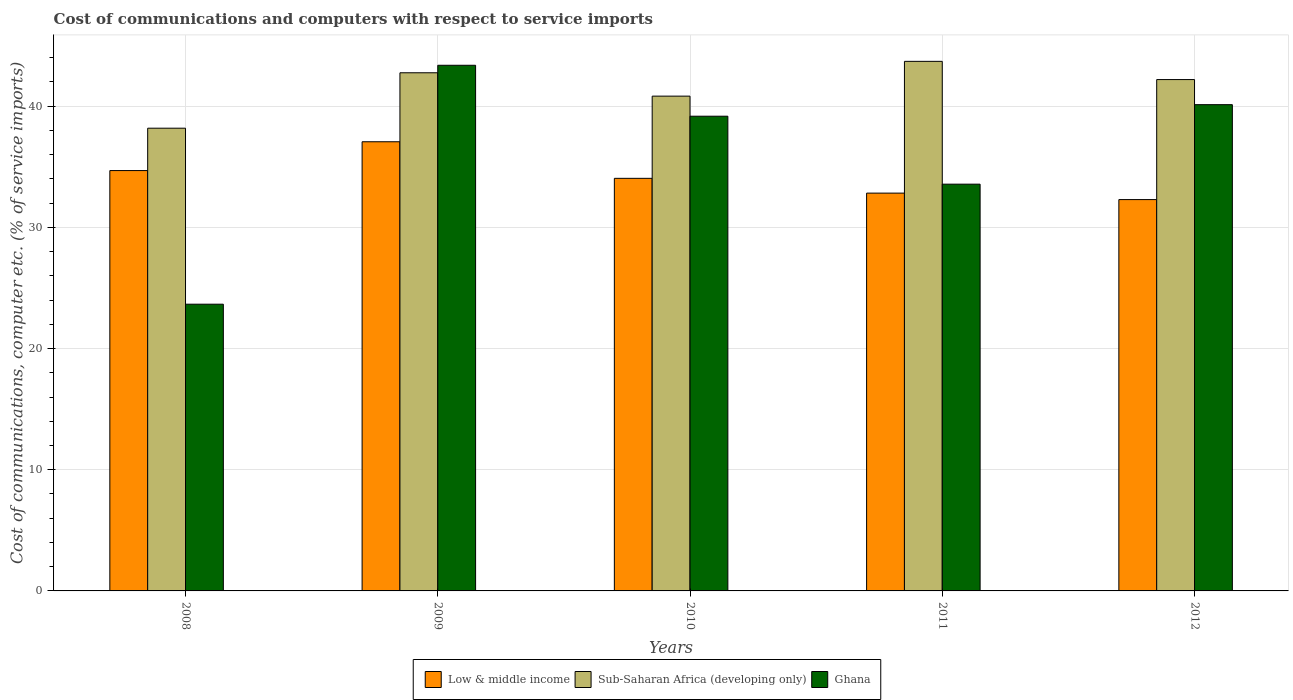How many different coloured bars are there?
Provide a short and direct response. 3. How many groups of bars are there?
Provide a short and direct response. 5. How many bars are there on the 2nd tick from the left?
Your answer should be very brief. 3. What is the cost of communications and computers in Low & middle income in 2011?
Your response must be concise. 32.83. Across all years, what is the maximum cost of communications and computers in Low & middle income?
Ensure brevity in your answer.  37.07. Across all years, what is the minimum cost of communications and computers in Ghana?
Your answer should be compact. 23.66. In which year was the cost of communications and computers in Ghana maximum?
Make the answer very short. 2009. What is the total cost of communications and computers in Low & middle income in the graph?
Keep it short and to the point. 170.93. What is the difference between the cost of communications and computers in Low & middle income in 2009 and that in 2011?
Offer a terse response. 4.24. What is the difference between the cost of communications and computers in Sub-Saharan Africa (developing only) in 2011 and the cost of communications and computers in Low & middle income in 2009?
Your answer should be compact. 6.64. What is the average cost of communications and computers in Low & middle income per year?
Keep it short and to the point. 34.19. In the year 2011, what is the difference between the cost of communications and computers in Ghana and cost of communications and computers in Sub-Saharan Africa (developing only)?
Give a very brief answer. -10.13. In how many years, is the cost of communications and computers in Sub-Saharan Africa (developing only) greater than 40 %?
Offer a very short reply. 4. What is the ratio of the cost of communications and computers in Low & middle income in 2010 to that in 2011?
Ensure brevity in your answer.  1.04. Is the cost of communications and computers in Ghana in 2010 less than that in 2012?
Your answer should be compact. Yes. What is the difference between the highest and the second highest cost of communications and computers in Low & middle income?
Your response must be concise. 2.38. What is the difference between the highest and the lowest cost of communications and computers in Low & middle income?
Make the answer very short. 4.77. Is the sum of the cost of communications and computers in Ghana in 2011 and 2012 greater than the maximum cost of communications and computers in Low & middle income across all years?
Offer a very short reply. Yes. How many bars are there?
Give a very brief answer. 15. Are all the bars in the graph horizontal?
Keep it short and to the point. No. How many years are there in the graph?
Provide a succinct answer. 5. Does the graph contain any zero values?
Offer a terse response. No. Where does the legend appear in the graph?
Your response must be concise. Bottom center. How are the legend labels stacked?
Your answer should be very brief. Horizontal. What is the title of the graph?
Offer a very short reply. Cost of communications and computers with respect to service imports. Does "Canada" appear as one of the legend labels in the graph?
Make the answer very short. No. What is the label or title of the Y-axis?
Provide a succinct answer. Cost of communications, computer etc. (% of service imports). What is the Cost of communications, computer etc. (% of service imports) of Low & middle income in 2008?
Give a very brief answer. 34.69. What is the Cost of communications, computer etc. (% of service imports) of Sub-Saharan Africa (developing only) in 2008?
Make the answer very short. 38.19. What is the Cost of communications, computer etc. (% of service imports) in Ghana in 2008?
Provide a short and direct response. 23.66. What is the Cost of communications, computer etc. (% of service imports) in Low & middle income in 2009?
Provide a succinct answer. 37.07. What is the Cost of communications, computer etc. (% of service imports) in Sub-Saharan Africa (developing only) in 2009?
Provide a succinct answer. 42.76. What is the Cost of communications, computer etc. (% of service imports) in Ghana in 2009?
Make the answer very short. 43.38. What is the Cost of communications, computer etc. (% of service imports) in Low & middle income in 2010?
Offer a terse response. 34.05. What is the Cost of communications, computer etc. (% of service imports) in Sub-Saharan Africa (developing only) in 2010?
Offer a very short reply. 40.83. What is the Cost of communications, computer etc. (% of service imports) in Ghana in 2010?
Your answer should be very brief. 39.18. What is the Cost of communications, computer etc. (% of service imports) of Low & middle income in 2011?
Your answer should be very brief. 32.83. What is the Cost of communications, computer etc. (% of service imports) in Sub-Saharan Africa (developing only) in 2011?
Your response must be concise. 43.7. What is the Cost of communications, computer etc. (% of service imports) of Ghana in 2011?
Your answer should be compact. 33.57. What is the Cost of communications, computer etc. (% of service imports) in Low & middle income in 2012?
Provide a short and direct response. 32.3. What is the Cost of communications, computer etc. (% of service imports) of Sub-Saharan Africa (developing only) in 2012?
Give a very brief answer. 42.2. What is the Cost of communications, computer etc. (% of service imports) in Ghana in 2012?
Your response must be concise. 40.13. Across all years, what is the maximum Cost of communications, computer etc. (% of service imports) of Low & middle income?
Provide a short and direct response. 37.07. Across all years, what is the maximum Cost of communications, computer etc. (% of service imports) in Sub-Saharan Africa (developing only)?
Your response must be concise. 43.7. Across all years, what is the maximum Cost of communications, computer etc. (% of service imports) in Ghana?
Offer a very short reply. 43.38. Across all years, what is the minimum Cost of communications, computer etc. (% of service imports) of Low & middle income?
Give a very brief answer. 32.3. Across all years, what is the minimum Cost of communications, computer etc. (% of service imports) of Sub-Saharan Africa (developing only)?
Your response must be concise. 38.19. Across all years, what is the minimum Cost of communications, computer etc. (% of service imports) in Ghana?
Ensure brevity in your answer.  23.66. What is the total Cost of communications, computer etc. (% of service imports) in Low & middle income in the graph?
Keep it short and to the point. 170.93. What is the total Cost of communications, computer etc. (% of service imports) of Sub-Saharan Africa (developing only) in the graph?
Give a very brief answer. 207.69. What is the total Cost of communications, computer etc. (% of service imports) of Ghana in the graph?
Offer a very short reply. 179.92. What is the difference between the Cost of communications, computer etc. (% of service imports) of Low & middle income in 2008 and that in 2009?
Provide a succinct answer. -2.38. What is the difference between the Cost of communications, computer etc. (% of service imports) of Sub-Saharan Africa (developing only) in 2008 and that in 2009?
Provide a succinct answer. -4.57. What is the difference between the Cost of communications, computer etc. (% of service imports) in Ghana in 2008 and that in 2009?
Provide a short and direct response. -19.72. What is the difference between the Cost of communications, computer etc. (% of service imports) in Low & middle income in 2008 and that in 2010?
Your response must be concise. 0.64. What is the difference between the Cost of communications, computer etc. (% of service imports) in Sub-Saharan Africa (developing only) in 2008 and that in 2010?
Offer a terse response. -2.65. What is the difference between the Cost of communications, computer etc. (% of service imports) of Ghana in 2008 and that in 2010?
Give a very brief answer. -15.51. What is the difference between the Cost of communications, computer etc. (% of service imports) of Low & middle income in 2008 and that in 2011?
Provide a short and direct response. 1.86. What is the difference between the Cost of communications, computer etc. (% of service imports) of Sub-Saharan Africa (developing only) in 2008 and that in 2011?
Your answer should be compact. -5.52. What is the difference between the Cost of communications, computer etc. (% of service imports) of Ghana in 2008 and that in 2011?
Offer a very short reply. -9.91. What is the difference between the Cost of communications, computer etc. (% of service imports) in Low & middle income in 2008 and that in 2012?
Keep it short and to the point. 2.39. What is the difference between the Cost of communications, computer etc. (% of service imports) of Sub-Saharan Africa (developing only) in 2008 and that in 2012?
Make the answer very short. -4.01. What is the difference between the Cost of communications, computer etc. (% of service imports) of Ghana in 2008 and that in 2012?
Keep it short and to the point. -16.47. What is the difference between the Cost of communications, computer etc. (% of service imports) of Low & middle income in 2009 and that in 2010?
Keep it short and to the point. 3.02. What is the difference between the Cost of communications, computer etc. (% of service imports) of Sub-Saharan Africa (developing only) in 2009 and that in 2010?
Your answer should be compact. 1.93. What is the difference between the Cost of communications, computer etc. (% of service imports) in Ghana in 2009 and that in 2010?
Offer a terse response. 4.2. What is the difference between the Cost of communications, computer etc. (% of service imports) of Low & middle income in 2009 and that in 2011?
Your answer should be very brief. 4.24. What is the difference between the Cost of communications, computer etc. (% of service imports) in Sub-Saharan Africa (developing only) in 2009 and that in 2011?
Ensure brevity in your answer.  -0.94. What is the difference between the Cost of communications, computer etc. (% of service imports) of Ghana in 2009 and that in 2011?
Ensure brevity in your answer.  9.81. What is the difference between the Cost of communications, computer etc. (% of service imports) in Low & middle income in 2009 and that in 2012?
Provide a short and direct response. 4.77. What is the difference between the Cost of communications, computer etc. (% of service imports) in Sub-Saharan Africa (developing only) in 2009 and that in 2012?
Your answer should be very brief. 0.56. What is the difference between the Cost of communications, computer etc. (% of service imports) of Ghana in 2009 and that in 2012?
Make the answer very short. 3.25. What is the difference between the Cost of communications, computer etc. (% of service imports) of Low & middle income in 2010 and that in 2011?
Ensure brevity in your answer.  1.22. What is the difference between the Cost of communications, computer etc. (% of service imports) in Sub-Saharan Africa (developing only) in 2010 and that in 2011?
Make the answer very short. -2.87. What is the difference between the Cost of communications, computer etc. (% of service imports) of Ghana in 2010 and that in 2011?
Ensure brevity in your answer.  5.61. What is the difference between the Cost of communications, computer etc. (% of service imports) in Low & middle income in 2010 and that in 2012?
Make the answer very short. 1.75. What is the difference between the Cost of communications, computer etc. (% of service imports) in Sub-Saharan Africa (developing only) in 2010 and that in 2012?
Give a very brief answer. -1.37. What is the difference between the Cost of communications, computer etc. (% of service imports) of Ghana in 2010 and that in 2012?
Keep it short and to the point. -0.95. What is the difference between the Cost of communications, computer etc. (% of service imports) of Low & middle income in 2011 and that in 2012?
Ensure brevity in your answer.  0.53. What is the difference between the Cost of communications, computer etc. (% of service imports) of Sub-Saharan Africa (developing only) in 2011 and that in 2012?
Give a very brief answer. 1.5. What is the difference between the Cost of communications, computer etc. (% of service imports) of Ghana in 2011 and that in 2012?
Make the answer very short. -6.56. What is the difference between the Cost of communications, computer etc. (% of service imports) in Low & middle income in 2008 and the Cost of communications, computer etc. (% of service imports) in Sub-Saharan Africa (developing only) in 2009?
Ensure brevity in your answer.  -8.07. What is the difference between the Cost of communications, computer etc. (% of service imports) of Low & middle income in 2008 and the Cost of communications, computer etc. (% of service imports) of Ghana in 2009?
Offer a very short reply. -8.69. What is the difference between the Cost of communications, computer etc. (% of service imports) in Sub-Saharan Africa (developing only) in 2008 and the Cost of communications, computer etc. (% of service imports) in Ghana in 2009?
Make the answer very short. -5.19. What is the difference between the Cost of communications, computer etc. (% of service imports) in Low & middle income in 2008 and the Cost of communications, computer etc. (% of service imports) in Sub-Saharan Africa (developing only) in 2010?
Your answer should be very brief. -6.14. What is the difference between the Cost of communications, computer etc. (% of service imports) in Low & middle income in 2008 and the Cost of communications, computer etc. (% of service imports) in Ghana in 2010?
Your answer should be compact. -4.49. What is the difference between the Cost of communications, computer etc. (% of service imports) of Sub-Saharan Africa (developing only) in 2008 and the Cost of communications, computer etc. (% of service imports) of Ghana in 2010?
Make the answer very short. -0.99. What is the difference between the Cost of communications, computer etc. (% of service imports) of Low & middle income in 2008 and the Cost of communications, computer etc. (% of service imports) of Sub-Saharan Africa (developing only) in 2011?
Provide a succinct answer. -9.01. What is the difference between the Cost of communications, computer etc. (% of service imports) in Low & middle income in 2008 and the Cost of communications, computer etc. (% of service imports) in Ghana in 2011?
Your answer should be very brief. 1.12. What is the difference between the Cost of communications, computer etc. (% of service imports) of Sub-Saharan Africa (developing only) in 2008 and the Cost of communications, computer etc. (% of service imports) of Ghana in 2011?
Your answer should be very brief. 4.62. What is the difference between the Cost of communications, computer etc. (% of service imports) in Low & middle income in 2008 and the Cost of communications, computer etc. (% of service imports) in Sub-Saharan Africa (developing only) in 2012?
Make the answer very short. -7.51. What is the difference between the Cost of communications, computer etc. (% of service imports) of Low & middle income in 2008 and the Cost of communications, computer etc. (% of service imports) of Ghana in 2012?
Offer a terse response. -5.44. What is the difference between the Cost of communications, computer etc. (% of service imports) of Sub-Saharan Africa (developing only) in 2008 and the Cost of communications, computer etc. (% of service imports) of Ghana in 2012?
Your response must be concise. -1.94. What is the difference between the Cost of communications, computer etc. (% of service imports) in Low & middle income in 2009 and the Cost of communications, computer etc. (% of service imports) in Sub-Saharan Africa (developing only) in 2010?
Ensure brevity in your answer.  -3.77. What is the difference between the Cost of communications, computer etc. (% of service imports) of Low & middle income in 2009 and the Cost of communications, computer etc. (% of service imports) of Ghana in 2010?
Provide a short and direct response. -2.11. What is the difference between the Cost of communications, computer etc. (% of service imports) in Sub-Saharan Africa (developing only) in 2009 and the Cost of communications, computer etc. (% of service imports) in Ghana in 2010?
Your response must be concise. 3.59. What is the difference between the Cost of communications, computer etc. (% of service imports) of Low & middle income in 2009 and the Cost of communications, computer etc. (% of service imports) of Sub-Saharan Africa (developing only) in 2011?
Make the answer very short. -6.64. What is the difference between the Cost of communications, computer etc. (% of service imports) of Low & middle income in 2009 and the Cost of communications, computer etc. (% of service imports) of Ghana in 2011?
Offer a very short reply. 3.5. What is the difference between the Cost of communications, computer etc. (% of service imports) of Sub-Saharan Africa (developing only) in 2009 and the Cost of communications, computer etc. (% of service imports) of Ghana in 2011?
Provide a short and direct response. 9.19. What is the difference between the Cost of communications, computer etc. (% of service imports) in Low & middle income in 2009 and the Cost of communications, computer etc. (% of service imports) in Sub-Saharan Africa (developing only) in 2012?
Your response must be concise. -5.13. What is the difference between the Cost of communications, computer etc. (% of service imports) in Low & middle income in 2009 and the Cost of communications, computer etc. (% of service imports) in Ghana in 2012?
Give a very brief answer. -3.06. What is the difference between the Cost of communications, computer etc. (% of service imports) of Sub-Saharan Africa (developing only) in 2009 and the Cost of communications, computer etc. (% of service imports) of Ghana in 2012?
Provide a short and direct response. 2.63. What is the difference between the Cost of communications, computer etc. (% of service imports) in Low & middle income in 2010 and the Cost of communications, computer etc. (% of service imports) in Sub-Saharan Africa (developing only) in 2011?
Offer a terse response. -9.65. What is the difference between the Cost of communications, computer etc. (% of service imports) of Low & middle income in 2010 and the Cost of communications, computer etc. (% of service imports) of Ghana in 2011?
Your response must be concise. 0.48. What is the difference between the Cost of communications, computer etc. (% of service imports) of Sub-Saharan Africa (developing only) in 2010 and the Cost of communications, computer etc. (% of service imports) of Ghana in 2011?
Your answer should be compact. 7.26. What is the difference between the Cost of communications, computer etc. (% of service imports) in Low & middle income in 2010 and the Cost of communications, computer etc. (% of service imports) in Sub-Saharan Africa (developing only) in 2012?
Make the answer very short. -8.15. What is the difference between the Cost of communications, computer etc. (% of service imports) in Low & middle income in 2010 and the Cost of communications, computer etc. (% of service imports) in Ghana in 2012?
Offer a very short reply. -6.08. What is the difference between the Cost of communications, computer etc. (% of service imports) in Sub-Saharan Africa (developing only) in 2010 and the Cost of communications, computer etc. (% of service imports) in Ghana in 2012?
Make the answer very short. 0.7. What is the difference between the Cost of communications, computer etc. (% of service imports) in Low & middle income in 2011 and the Cost of communications, computer etc. (% of service imports) in Sub-Saharan Africa (developing only) in 2012?
Your answer should be very brief. -9.37. What is the difference between the Cost of communications, computer etc. (% of service imports) of Low & middle income in 2011 and the Cost of communications, computer etc. (% of service imports) of Ghana in 2012?
Ensure brevity in your answer.  -7.3. What is the difference between the Cost of communications, computer etc. (% of service imports) in Sub-Saharan Africa (developing only) in 2011 and the Cost of communications, computer etc. (% of service imports) in Ghana in 2012?
Give a very brief answer. 3.57. What is the average Cost of communications, computer etc. (% of service imports) in Low & middle income per year?
Your answer should be compact. 34.19. What is the average Cost of communications, computer etc. (% of service imports) in Sub-Saharan Africa (developing only) per year?
Offer a very short reply. 41.54. What is the average Cost of communications, computer etc. (% of service imports) in Ghana per year?
Your answer should be compact. 35.98. In the year 2008, what is the difference between the Cost of communications, computer etc. (% of service imports) of Low & middle income and Cost of communications, computer etc. (% of service imports) of Sub-Saharan Africa (developing only)?
Offer a very short reply. -3.5. In the year 2008, what is the difference between the Cost of communications, computer etc. (% of service imports) in Low & middle income and Cost of communications, computer etc. (% of service imports) in Ghana?
Offer a very short reply. 11.03. In the year 2008, what is the difference between the Cost of communications, computer etc. (% of service imports) of Sub-Saharan Africa (developing only) and Cost of communications, computer etc. (% of service imports) of Ghana?
Provide a short and direct response. 14.53. In the year 2009, what is the difference between the Cost of communications, computer etc. (% of service imports) in Low & middle income and Cost of communications, computer etc. (% of service imports) in Sub-Saharan Africa (developing only)?
Provide a succinct answer. -5.69. In the year 2009, what is the difference between the Cost of communications, computer etc. (% of service imports) in Low & middle income and Cost of communications, computer etc. (% of service imports) in Ghana?
Ensure brevity in your answer.  -6.31. In the year 2009, what is the difference between the Cost of communications, computer etc. (% of service imports) of Sub-Saharan Africa (developing only) and Cost of communications, computer etc. (% of service imports) of Ghana?
Provide a succinct answer. -0.62. In the year 2010, what is the difference between the Cost of communications, computer etc. (% of service imports) of Low & middle income and Cost of communications, computer etc. (% of service imports) of Sub-Saharan Africa (developing only)?
Provide a short and direct response. -6.78. In the year 2010, what is the difference between the Cost of communications, computer etc. (% of service imports) in Low & middle income and Cost of communications, computer etc. (% of service imports) in Ghana?
Your answer should be compact. -5.13. In the year 2010, what is the difference between the Cost of communications, computer etc. (% of service imports) in Sub-Saharan Africa (developing only) and Cost of communications, computer etc. (% of service imports) in Ghana?
Provide a short and direct response. 1.66. In the year 2011, what is the difference between the Cost of communications, computer etc. (% of service imports) of Low & middle income and Cost of communications, computer etc. (% of service imports) of Sub-Saharan Africa (developing only)?
Keep it short and to the point. -10.87. In the year 2011, what is the difference between the Cost of communications, computer etc. (% of service imports) of Low & middle income and Cost of communications, computer etc. (% of service imports) of Ghana?
Offer a terse response. -0.74. In the year 2011, what is the difference between the Cost of communications, computer etc. (% of service imports) in Sub-Saharan Africa (developing only) and Cost of communications, computer etc. (% of service imports) in Ghana?
Offer a very short reply. 10.13. In the year 2012, what is the difference between the Cost of communications, computer etc. (% of service imports) of Low & middle income and Cost of communications, computer etc. (% of service imports) of Sub-Saharan Africa (developing only)?
Offer a very short reply. -9.9. In the year 2012, what is the difference between the Cost of communications, computer etc. (% of service imports) in Low & middle income and Cost of communications, computer etc. (% of service imports) in Ghana?
Your answer should be very brief. -7.83. In the year 2012, what is the difference between the Cost of communications, computer etc. (% of service imports) of Sub-Saharan Africa (developing only) and Cost of communications, computer etc. (% of service imports) of Ghana?
Your answer should be very brief. 2.07. What is the ratio of the Cost of communications, computer etc. (% of service imports) of Low & middle income in 2008 to that in 2009?
Your response must be concise. 0.94. What is the ratio of the Cost of communications, computer etc. (% of service imports) in Sub-Saharan Africa (developing only) in 2008 to that in 2009?
Your answer should be compact. 0.89. What is the ratio of the Cost of communications, computer etc. (% of service imports) in Ghana in 2008 to that in 2009?
Give a very brief answer. 0.55. What is the ratio of the Cost of communications, computer etc. (% of service imports) in Low & middle income in 2008 to that in 2010?
Your answer should be very brief. 1.02. What is the ratio of the Cost of communications, computer etc. (% of service imports) of Sub-Saharan Africa (developing only) in 2008 to that in 2010?
Make the answer very short. 0.94. What is the ratio of the Cost of communications, computer etc. (% of service imports) of Ghana in 2008 to that in 2010?
Your answer should be compact. 0.6. What is the ratio of the Cost of communications, computer etc. (% of service imports) of Low & middle income in 2008 to that in 2011?
Your answer should be compact. 1.06. What is the ratio of the Cost of communications, computer etc. (% of service imports) of Sub-Saharan Africa (developing only) in 2008 to that in 2011?
Provide a short and direct response. 0.87. What is the ratio of the Cost of communications, computer etc. (% of service imports) of Ghana in 2008 to that in 2011?
Provide a short and direct response. 0.7. What is the ratio of the Cost of communications, computer etc. (% of service imports) in Low & middle income in 2008 to that in 2012?
Your answer should be compact. 1.07. What is the ratio of the Cost of communications, computer etc. (% of service imports) in Sub-Saharan Africa (developing only) in 2008 to that in 2012?
Offer a terse response. 0.9. What is the ratio of the Cost of communications, computer etc. (% of service imports) in Ghana in 2008 to that in 2012?
Keep it short and to the point. 0.59. What is the ratio of the Cost of communications, computer etc. (% of service imports) in Low & middle income in 2009 to that in 2010?
Make the answer very short. 1.09. What is the ratio of the Cost of communications, computer etc. (% of service imports) in Sub-Saharan Africa (developing only) in 2009 to that in 2010?
Ensure brevity in your answer.  1.05. What is the ratio of the Cost of communications, computer etc. (% of service imports) in Ghana in 2009 to that in 2010?
Offer a terse response. 1.11. What is the ratio of the Cost of communications, computer etc. (% of service imports) of Low & middle income in 2009 to that in 2011?
Ensure brevity in your answer.  1.13. What is the ratio of the Cost of communications, computer etc. (% of service imports) in Sub-Saharan Africa (developing only) in 2009 to that in 2011?
Keep it short and to the point. 0.98. What is the ratio of the Cost of communications, computer etc. (% of service imports) in Ghana in 2009 to that in 2011?
Offer a terse response. 1.29. What is the ratio of the Cost of communications, computer etc. (% of service imports) of Low & middle income in 2009 to that in 2012?
Your answer should be compact. 1.15. What is the ratio of the Cost of communications, computer etc. (% of service imports) in Sub-Saharan Africa (developing only) in 2009 to that in 2012?
Your answer should be compact. 1.01. What is the ratio of the Cost of communications, computer etc. (% of service imports) of Ghana in 2009 to that in 2012?
Offer a very short reply. 1.08. What is the ratio of the Cost of communications, computer etc. (% of service imports) in Low & middle income in 2010 to that in 2011?
Give a very brief answer. 1.04. What is the ratio of the Cost of communications, computer etc. (% of service imports) of Sub-Saharan Africa (developing only) in 2010 to that in 2011?
Your answer should be compact. 0.93. What is the ratio of the Cost of communications, computer etc. (% of service imports) of Ghana in 2010 to that in 2011?
Offer a terse response. 1.17. What is the ratio of the Cost of communications, computer etc. (% of service imports) of Low & middle income in 2010 to that in 2012?
Provide a succinct answer. 1.05. What is the ratio of the Cost of communications, computer etc. (% of service imports) in Sub-Saharan Africa (developing only) in 2010 to that in 2012?
Your response must be concise. 0.97. What is the ratio of the Cost of communications, computer etc. (% of service imports) in Ghana in 2010 to that in 2012?
Offer a very short reply. 0.98. What is the ratio of the Cost of communications, computer etc. (% of service imports) of Low & middle income in 2011 to that in 2012?
Keep it short and to the point. 1.02. What is the ratio of the Cost of communications, computer etc. (% of service imports) of Sub-Saharan Africa (developing only) in 2011 to that in 2012?
Keep it short and to the point. 1.04. What is the ratio of the Cost of communications, computer etc. (% of service imports) of Ghana in 2011 to that in 2012?
Ensure brevity in your answer.  0.84. What is the difference between the highest and the second highest Cost of communications, computer etc. (% of service imports) in Low & middle income?
Offer a terse response. 2.38. What is the difference between the highest and the second highest Cost of communications, computer etc. (% of service imports) in Sub-Saharan Africa (developing only)?
Your answer should be compact. 0.94. What is the difference between the highest and the second highest Cost of communications, computer etc. (% of service imports) in Ghana?
Make the answer very short. 3.25. What is the difference between the highest and the lowest Cost of communications, computer etc. (% of service imports) of Low & middle income?
Make the answer very short. 4.77. What is the difference between the highest and the lowest Cost of communications, computer etc. (% of service imports) in Sub-Saharan Africa (developing only)?
Make the answer very short. 5.52. What is the difference between the highest and the lowest Cost of communications, computer etc. (% of service imports) in Ghana?
Your answer should be very brief. 19.72. 